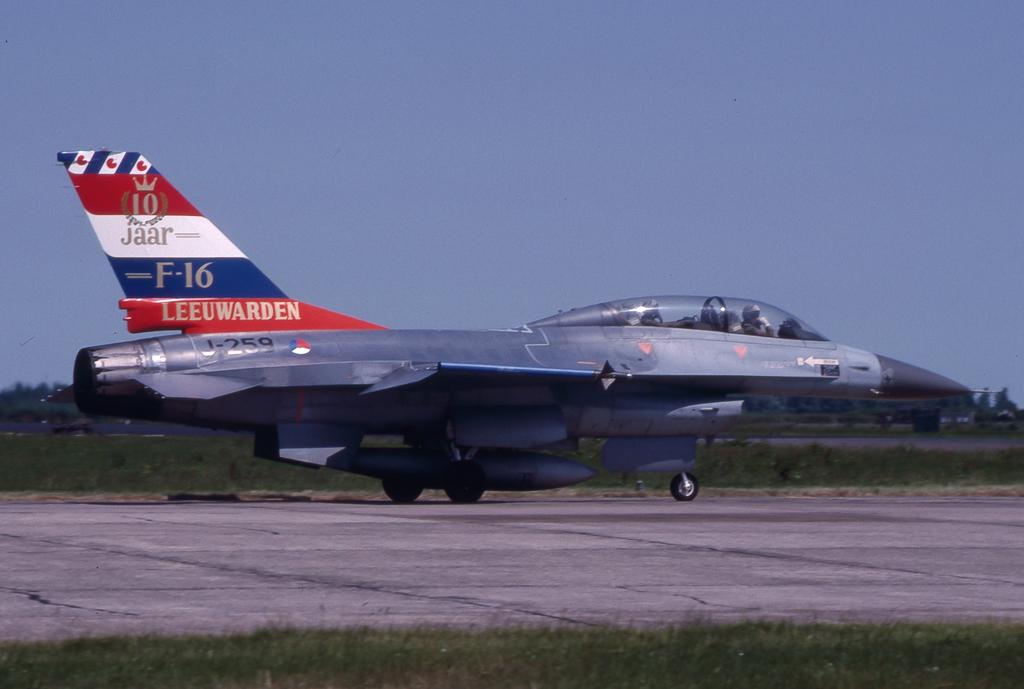What type of jet is this?
Your response must be concise. F-16. What airline is this?
Give a very brief answer. Jaar. 